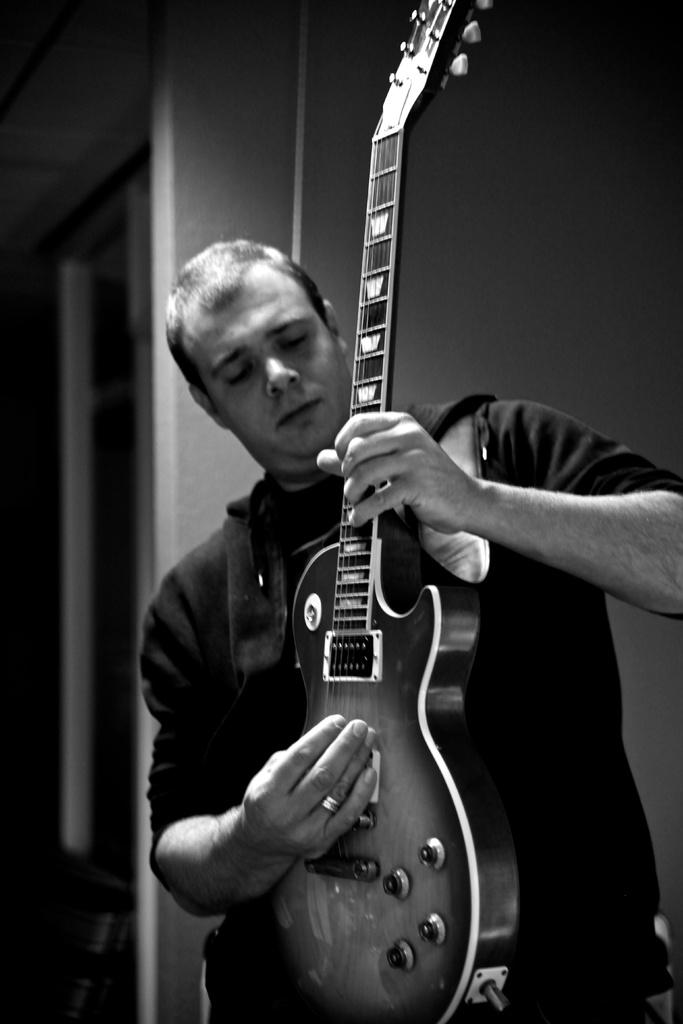What is the color scheme of the image? The image is in black and white color. What is the person in the image doing? The person is holding a guitar and playing it. What is the person wearing in the image? The person is wearing a black T-shirt. What can be seen in the background of the image? There is a window in the background. How many hands are visible on the stem of the guitar in the image? There is no stem visible on the guitar in the image, and therefore no hands can be seen on it. Can you hear the person playing the guitar in the image? The image is a still photograph, so we cannot hear the person playing the guitar. 